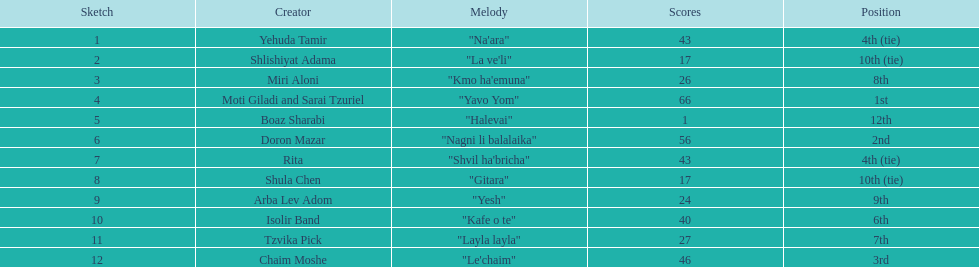What artist received the least amount of points in the competition? Boaz Sharabi. 